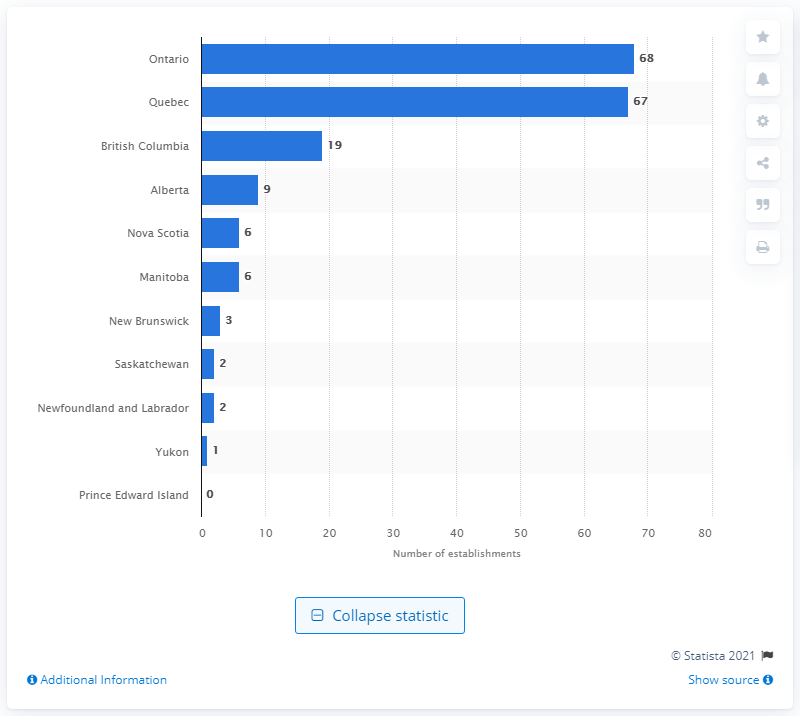Outline some significant characteristics in this image. As of December 2019, there were 68 leather and allied product manufacturing establishments in Ontario. 